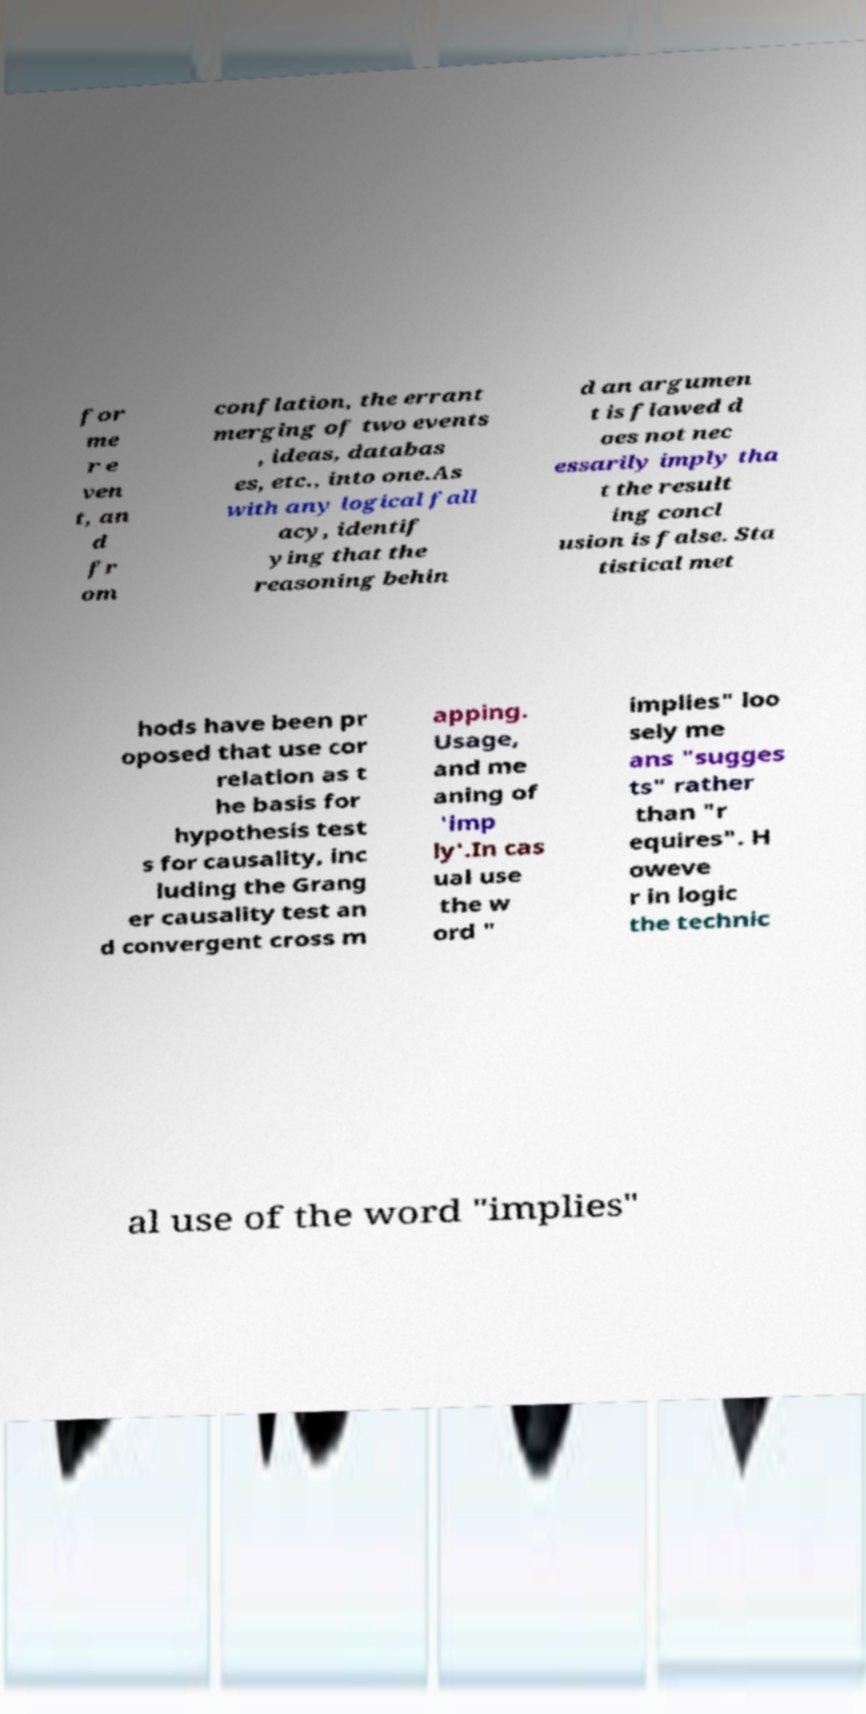What messages or text are displayed in this image? I need them in a readable, typed format. for me r e ven t, an d fr om conflation, the errant merging of two events , ideas, databas es, etc., into one.As with any logical fall acy, identif ying that the reasoning behin d an argumen t is flawed d oes not nec essarily imply tha t the result ing concl usion is false. Sta tistical met hods have been pr oposed that use cor relation as t he basis for hypothesis test s for causality, inc luding the Grang er causality test an d convergent cross m apping. Usage, and me aning of 'imp ly'.In cas ual use the w ord " implies" loo sely me ans "sugges ts" rather than "r equires". H oweve r in logic the technic al use of the word "implies" 